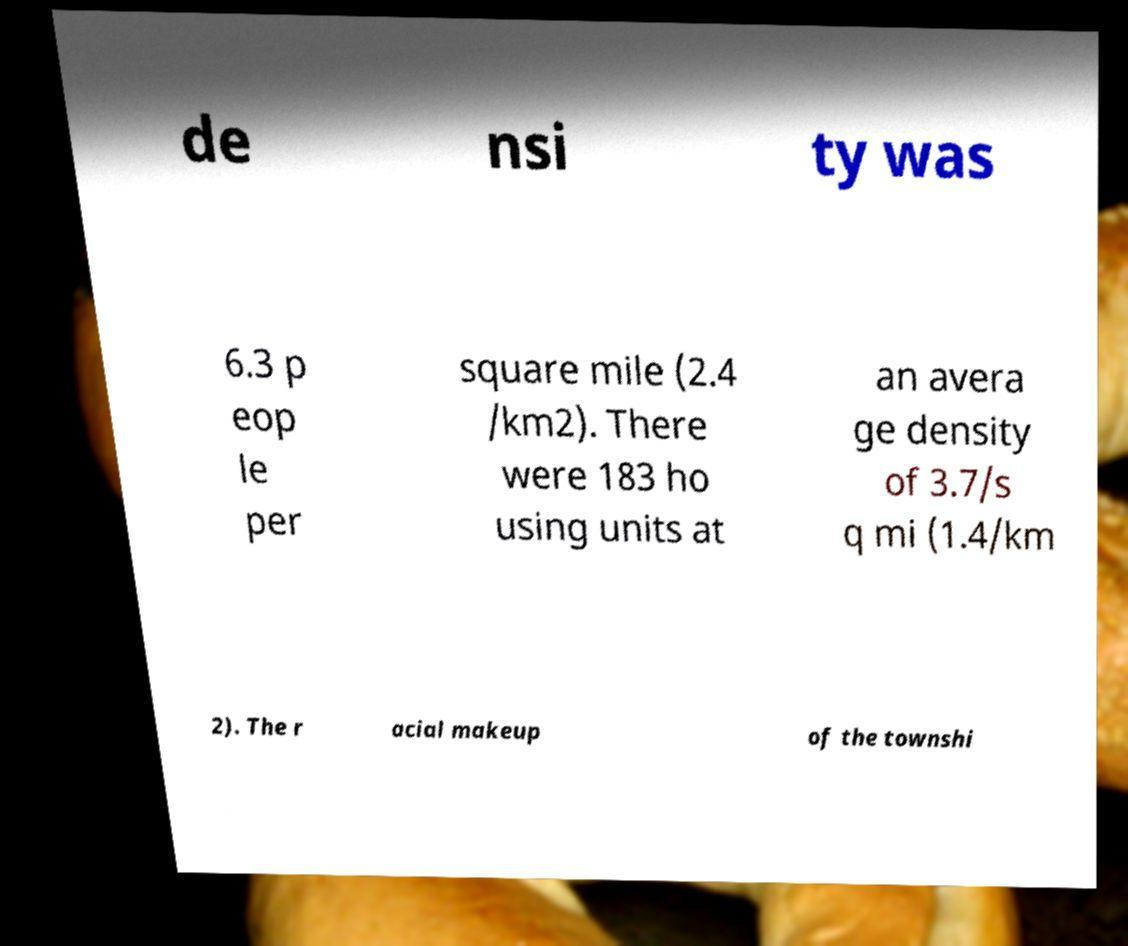For documentation purposes, I need the text within this image transcribed. Could you provide that? de nsi ty was 6.3 p eop le per square mile (2.4 /km2). There were 183 ho using units at an avera ge density of 3.7/s q mi (1.4/km 2). The r acial makeup of the townshi 